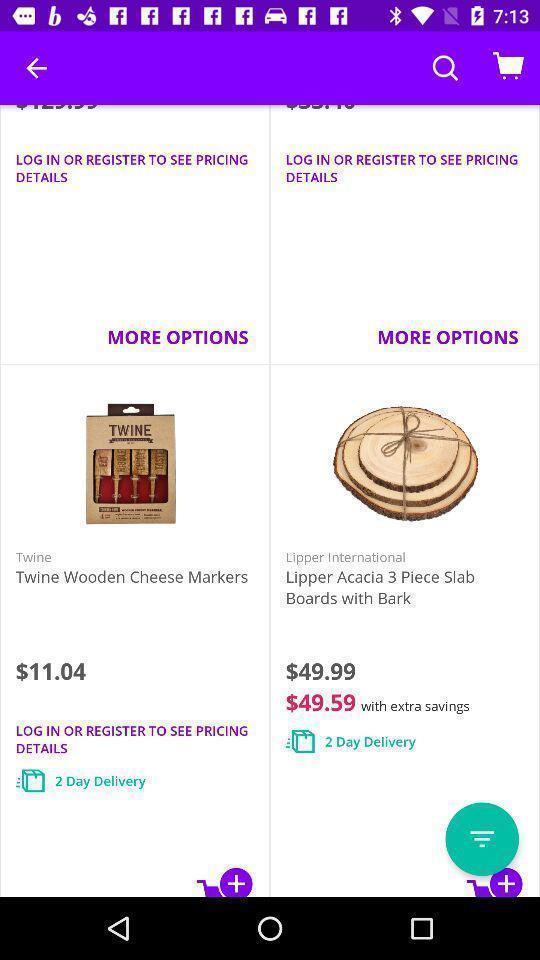Describe this image in words. Screen showing the products in list in shopping app. 